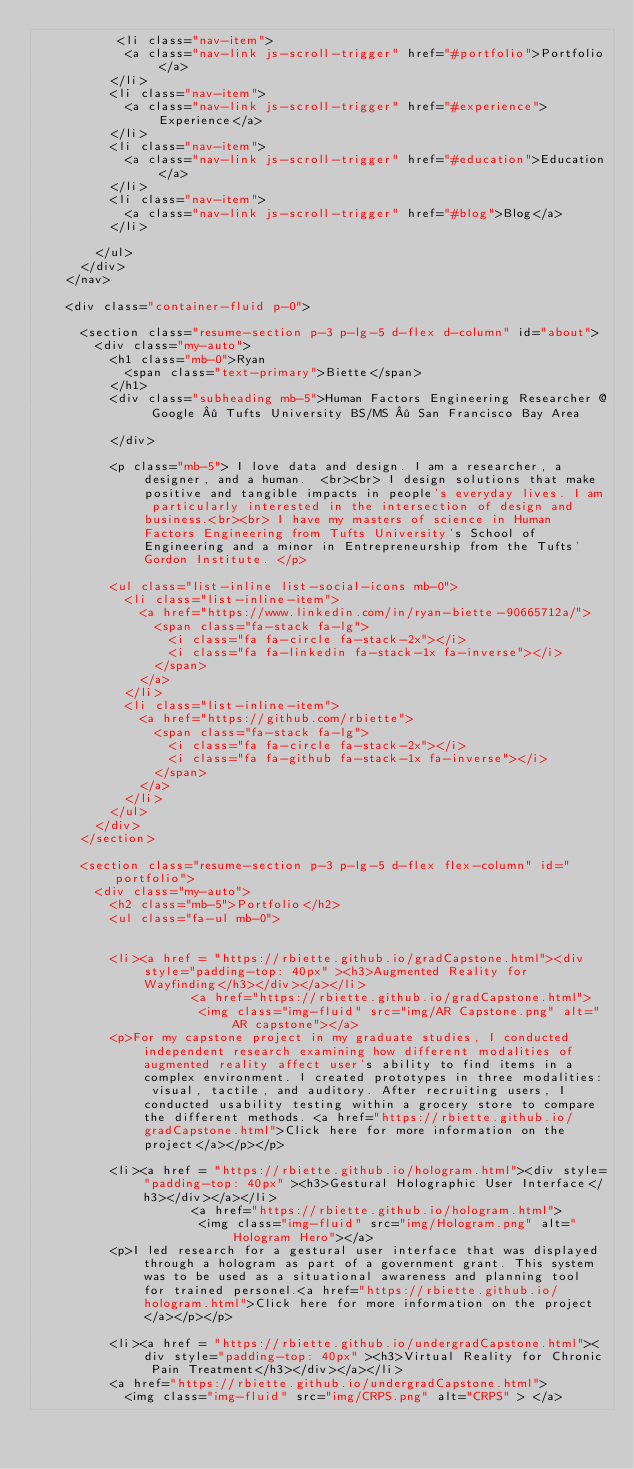Convert code to text. <code><loc_0><loc_0><loc_500><loc_500><_HTML_>           <li class="nav-item">
            <a class="nav-link js-scroll-trigger" href="#portfolio">Portfolio</a>
          </li>
          <li class="nav-item">
            <a class="nav-link js-scroll-trigger" href="#experience">Experience</a>
          </li>
          <li class="nav-item">
            <a class="nav-link js-scroll-trigger" href="#education">Education</a>
          </li>
          <li class="nav-item">
            <a class="nav-link js-scroll-trigger" href="#blog">Blog</a>
          </li>

        </ul>
      </div>
    </nav>

    <div class="container-fluid p-0">

      <section class="resume-section p-3 p-lg-5 d-flex d-column" id="about">
        <div class="my-auto">
          <h1 class="mb-0">Ryan
            <span class="text-primary">Biette</span>
          </h1>
          <div class="subheading mb-5">Human Factors Engineering Researcher @ Google · Tufts University BS/MS · San Francisco Bay Area 

          </div>

          <p class="mb-5"> I love data and design. I am a researcher, a designer, and a human.  <br><br> I design solutions that make positive and tangible impacts in people's everyday lives. I am particularly interested in the intersection of design and business.<br><br> I have my masters of science in Human Factors Engineering from Tufts University's School of Engineering and a minor in Entrepreneurship from the Tufts' Gordon Institute. </p>

          <ul class="list-inline list-social-icons mb-0">
            <li class="list-inline-item">
              <a href="https://www.linkedin.com/in/ryan-biette-90665712a/">
                <span class="fa-stack fa-lg">
                  <i class="fa fa-circle fa-stack-2x"></i>
                  <i class="fa fa-linkedin fa-stack-1x fa-inverse"></i>
                </span>
              </a>
            </li>
            <li class="list-inline-item">
              <a href="https://github.com/rbiette">
                <span class="fa-stack fa-lg">
                  <i class="fa fa-circle fa-stack-2x"></i>
                  <i class="fa fa-github fa-stack-1x fa-inverse"></i>
                </span>
              </a>
            </li>
          </ul>
        </div>
      </section>

      <section class="resume-section p-3 p-lg-5 d-flex flex-column" id="portfolio">
        <div class="my-auto">
          <h2 class="mb-5">Portfolio</h2>
          <ul class="fa-ul mb-0">


          <li><a href = "https://rbiette.github.io/gradCapstone.html"><div style="padding-top: 40px" ><h3>Augmented Reality for Wayfinding</h3></div></a></li>
                     <a href="https://rbiette.github.io/gradCapstone.html"> 
                      <img class="img-fluid" src="img/AR Capstone.png" alt="AR capstone"></a> 
          <p>For my capstone project in my graduate studies, I conducted independent research examining how different modalities of augmented reality affect user's ability to find items in a complex environment. I created prototypes in three modalities: visual, tactile, and auditory. After recruiting users, I conducted usability testing within a grocery store to compare the different methods. <a href="https://rbiette.github.io/gradCapstone.html">Click here for more information on the project</a></p></p> 

          <li><a href = "https://rbiette.github.io/hologram.html"><div style="padding-top: 40px" ><h3>Gestural Holographic User Interface</h3></div></a></li>
                     <a href="https://rbiette.github.io/hologram.html"> 
                      <img class="img-fluid" src="img/Hologram.png" alt="Hologram Hero"></a> 
          <p>I led research for a gestural user interface that was displayed through a hologram as part of a government grant. This system was to be used as a situational awareness and planning tool for trained personel.<a href="https://rbiette.github.io/hologram.html">Click here for more information on the project</a></p></p> 

          <li><a href = "https://rbiette.github.io/undergradCapstone.html"><div style="padding-top: 40px" ><h3>Virtual Reality for Chronic Pain Treatment</h3></div></a></li>
          <a href="https://rbiette.github.io/undergradCapstone.html"> 
            <img class="img-fluid" src="img/CRPS.png" alt="CRPS" > </a></code> 